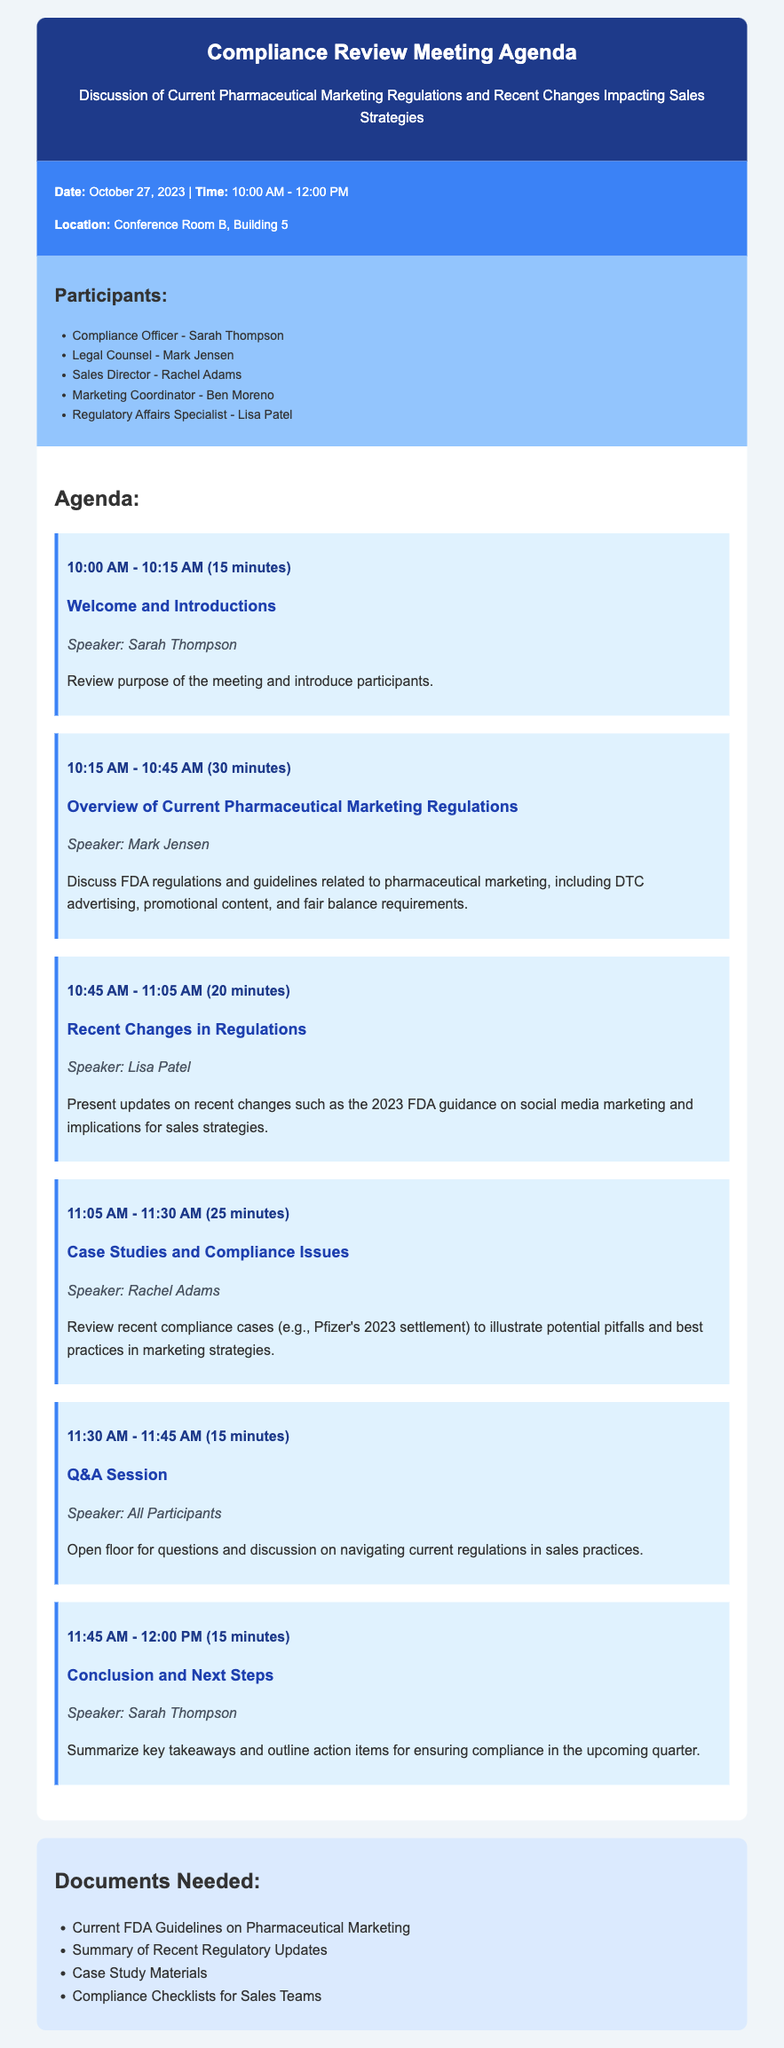what is the date of the meeting? The date of the meeting is specified in the document under the meeting info section.
Answer: October 27, 2023 what time does the meeting start? The meeting time is listed in the document's meeting info section.
Answer: 10:00 AM who is the speaker for the overview of current pharmaceutical marketing regulations? The speaker for this topic is identified in the agenda items section.
Answer: Mark Jensen how long is the Q&A session scheduled to last? The duration of the Q&A session is mentioned alongside the agenda item in the document.
Answer: 15 minutes what is one document needed for the meeting? The documents needed are listed in the documents section of the agenda.
Answer: Current FDA Guidelines on Pharmaceutical Marketing which compliance case will be discussed during the meeting? The specific compliance case discussed is mentioned under the case studies agenda item.
Answer: Pfizer's 2023 settlement how many participants are listed in the document? The number of participants can be determined by counting the names listed in the participants section.
Answer: Five what is the main purpose of the meeting? The purpose of the meeting is described in the header of the document.
Answer: Discussion of Current Pharmaceutical Marketing Regulations and Recent Changes Impacting Sales Strategies who will conclude the meeting? The document specifies who will lead the conclusion portion in the agenda items section.
Answer: Sarah Thompson 